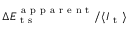Convert formula to latex. <formula><loc_0><loc_0><loc_500><loc_500>\Delta E _ { t s } ^ { a p p a r e n t } / \langle I _ { t } \rangle</formula> 